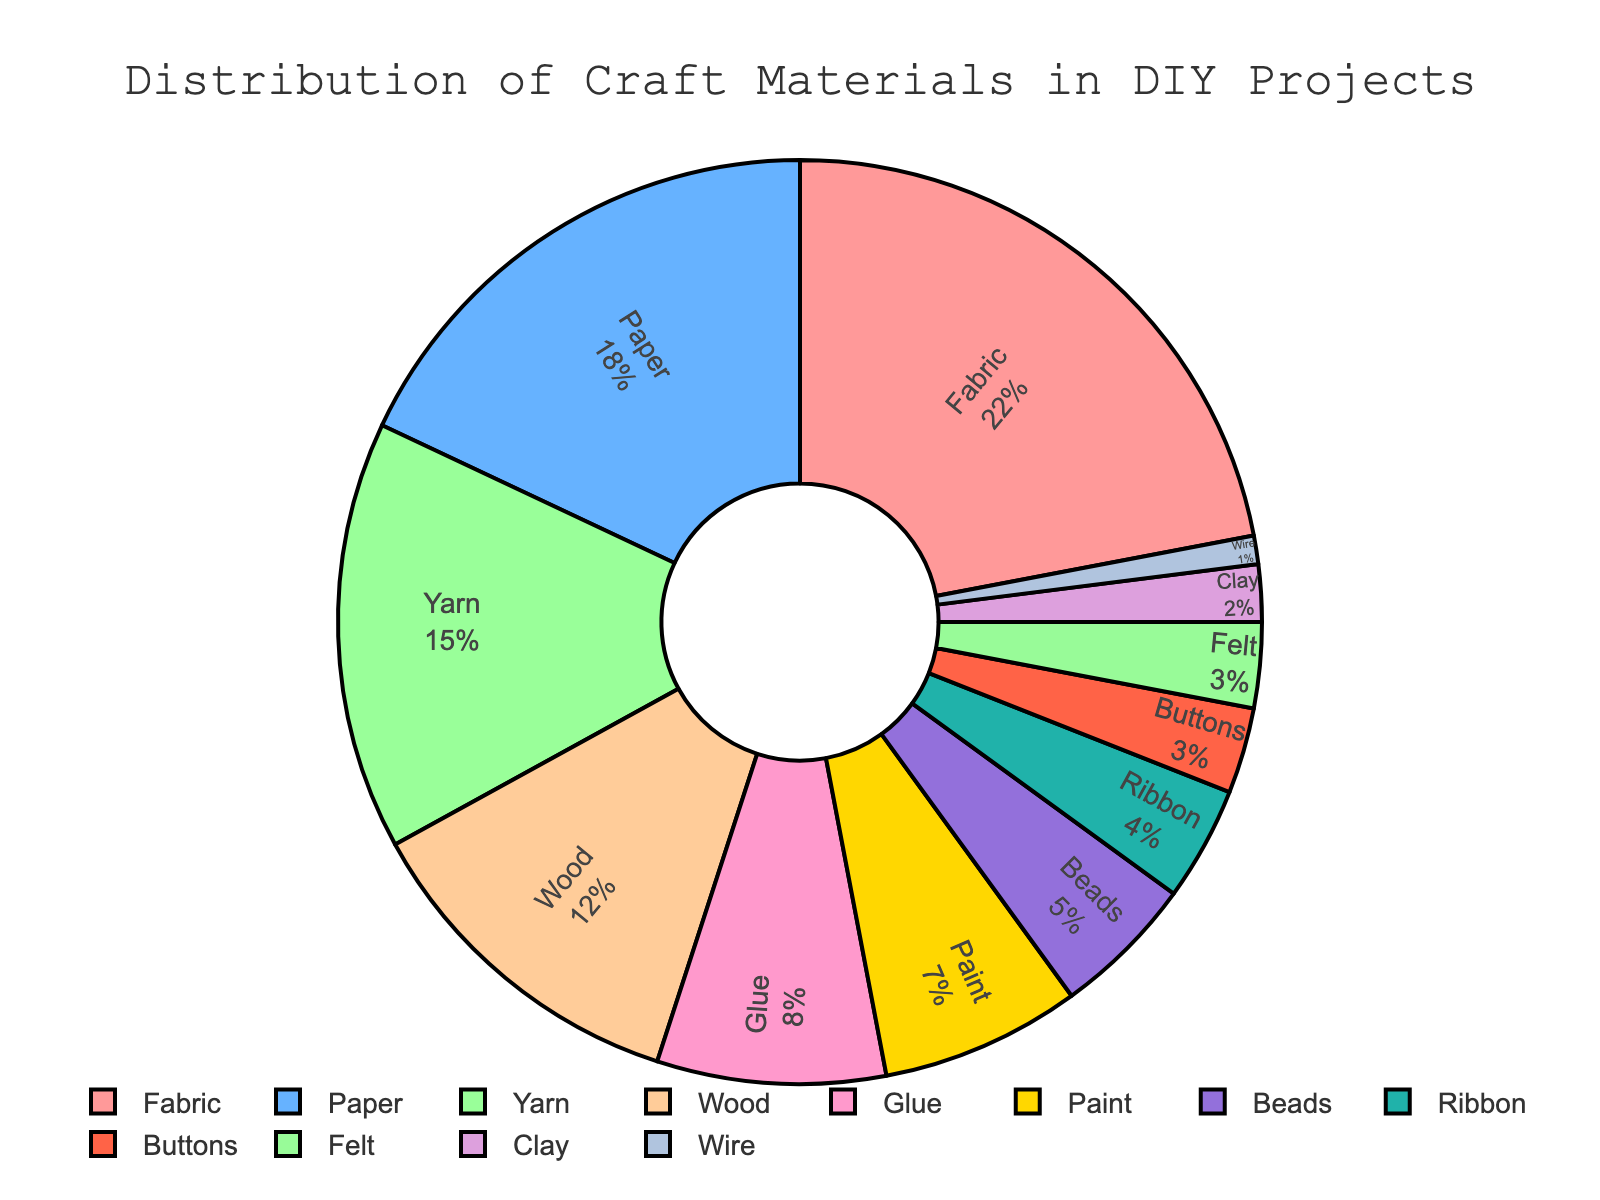Which material has the highest percentage in the DIY projects? The chart shows that Fabric has the largest slice, labeled with 22%.
Answer: Fabric Which two materials together make up 30% of the distribution? Yarn has 15% and Wood has 12%, totaling 27%. Adding Glue with 8% makes 35%, but adding Paint with 7% makes 34%, which includes more than 30%. The closest pairs less than and nearest to 30% are Paper (18%) and Paint (7%) = 25%. So, Yarn (15%) and Glue (8%) = 23% and Ribbon makes (4%) = 27%.
Answer: Fabric and Paper Which material has the smallest percentage? The smallest slice labeled with 1% represents Wire.
Answer: Wire How much more percentage is Fabric used than Yarn in DIY projects? Fabric is 22% and Yarn is 15%. The difference is 22% - 15% = 7%.
Answer: 7% If the percentage of Wood and Glue are combined, what would be their total? Wood is 12% and Glue is 8%. The combined total is 12% + 8% = 20%.
Answer: 20% What is the combined percentage of Beads, Ribbon, and Buttons? Beads are 5%, Ribbon 4%, and Buttons 3%. Combined, 5% + 4% + 3% = 12%.
Answer: 12% Is Paint used more or less than Yarn? The chart shows Paint at 7% and Yarn at 15%. Therefore, Paint is used less than Yarn.
Answer: Less What's the percentage difference between the usage of Paper and Felt? Paper is 18% and Felt is 3%. The difference is 18% - 3% = 15%.
Answer: 15% Which of the materials has a percentage closest to 5%? Beads is at 5%, representing the exact percentage close to it.
Answer: Beads How many materials have a usage percentage above 10%? Materials above 10% are Fabric (22%), Paper (18%), and Yarn (15%), totaling 3 materials.
Answer: 3 